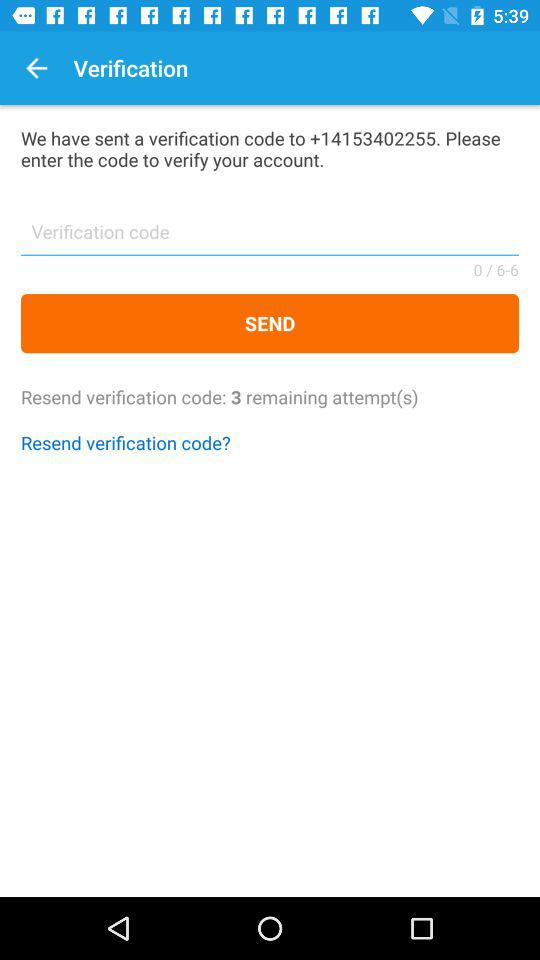How many attempts are remaining? There are 3 remaining attempts. 